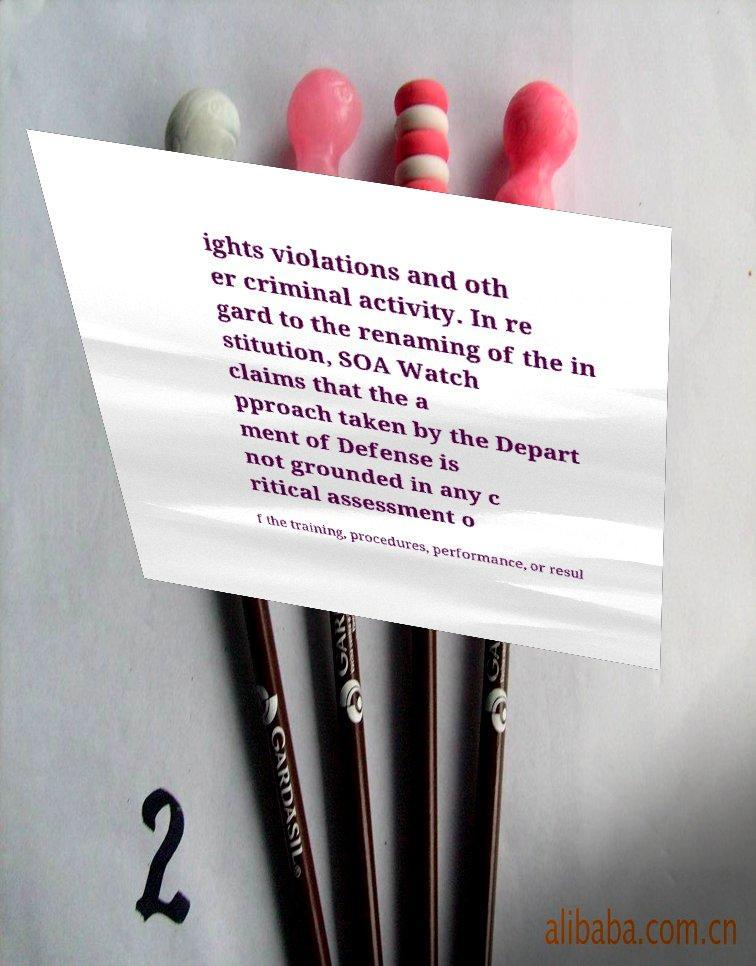I need the written content from this picture converted into text. Can you do that? ights violations and oth er criminal activity. In re gard to the renaming of the in stitution, SOA Watch claims that the a pproach taken by the Depart ment of Defense is not grounded in any c ritical assessment o f the training, procedures, performance, or resul 